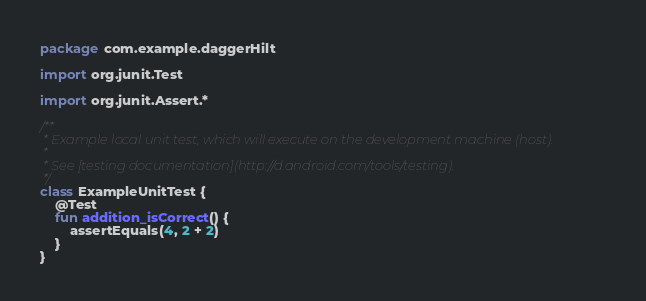<code> <loc_0><loc_0><loc_500><loc_500><_Kotlin_>package com.example.daggerHilt

import org.junit.Test

import org.junit.Assert.*

/**
 * Example local unit test, which will execute on the development machine (host).
 *
 * See [testing documentation](http://d.android.com/tools/testing).
 */
class ExampleUnitTest {
    @Test
    fun addition_isCorrect() {
        assertEquals(4, 2 + 2)
    }
}</code> 